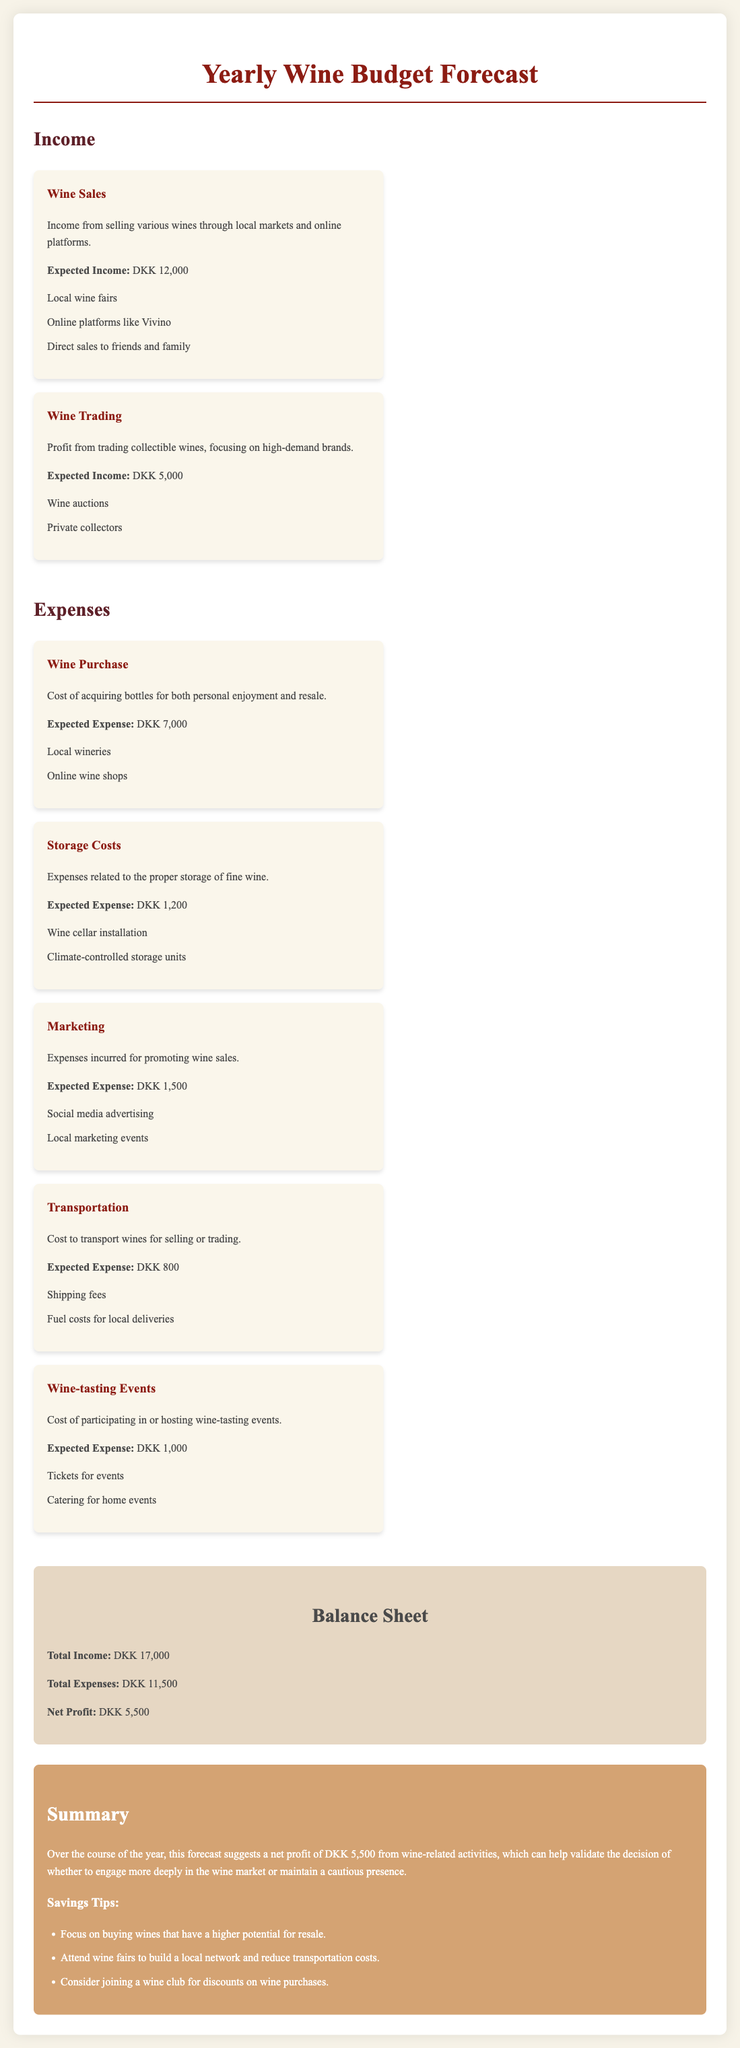What is the expected income from wine sales? The expected income from wine sales is mentioned in the income section of the document.
Answer: DKK 12,000 What is the total expected expense? The total expected expense is the sum of all expenses listed in the document.
Answer: DKK 11,500 What is the net profit according to the balance sheet? The net profit is calculated by subtracting total expenses from total income.
Answer: DKK 5,500 How much is allocated for storage costs? The specific amount for storage costs is provided in the expenses section.
Answer: DKK 1,200 What types of platforms are included in wine sales? The document outlines specific platforms where wine sales occur.
Answer: Local markets and online platforms What is the expected income from wine trading? The expected income specifically from wine trading is detailed in the income section.
Answer: DKK 5,000 Which expense category has the highest allocation? This question asks for a comparison of the expense categories listed.
Answer: Wine Purchase How much is spent on marketing? The expense incurred for marketing is indicated in the document.
Answer: DKK 1,500 What is the summary’s suggestion for potential savings? The summary section offers tips for savings on wine-related activities.
Answer: Focus on buying wines that have a higher potential for resale 